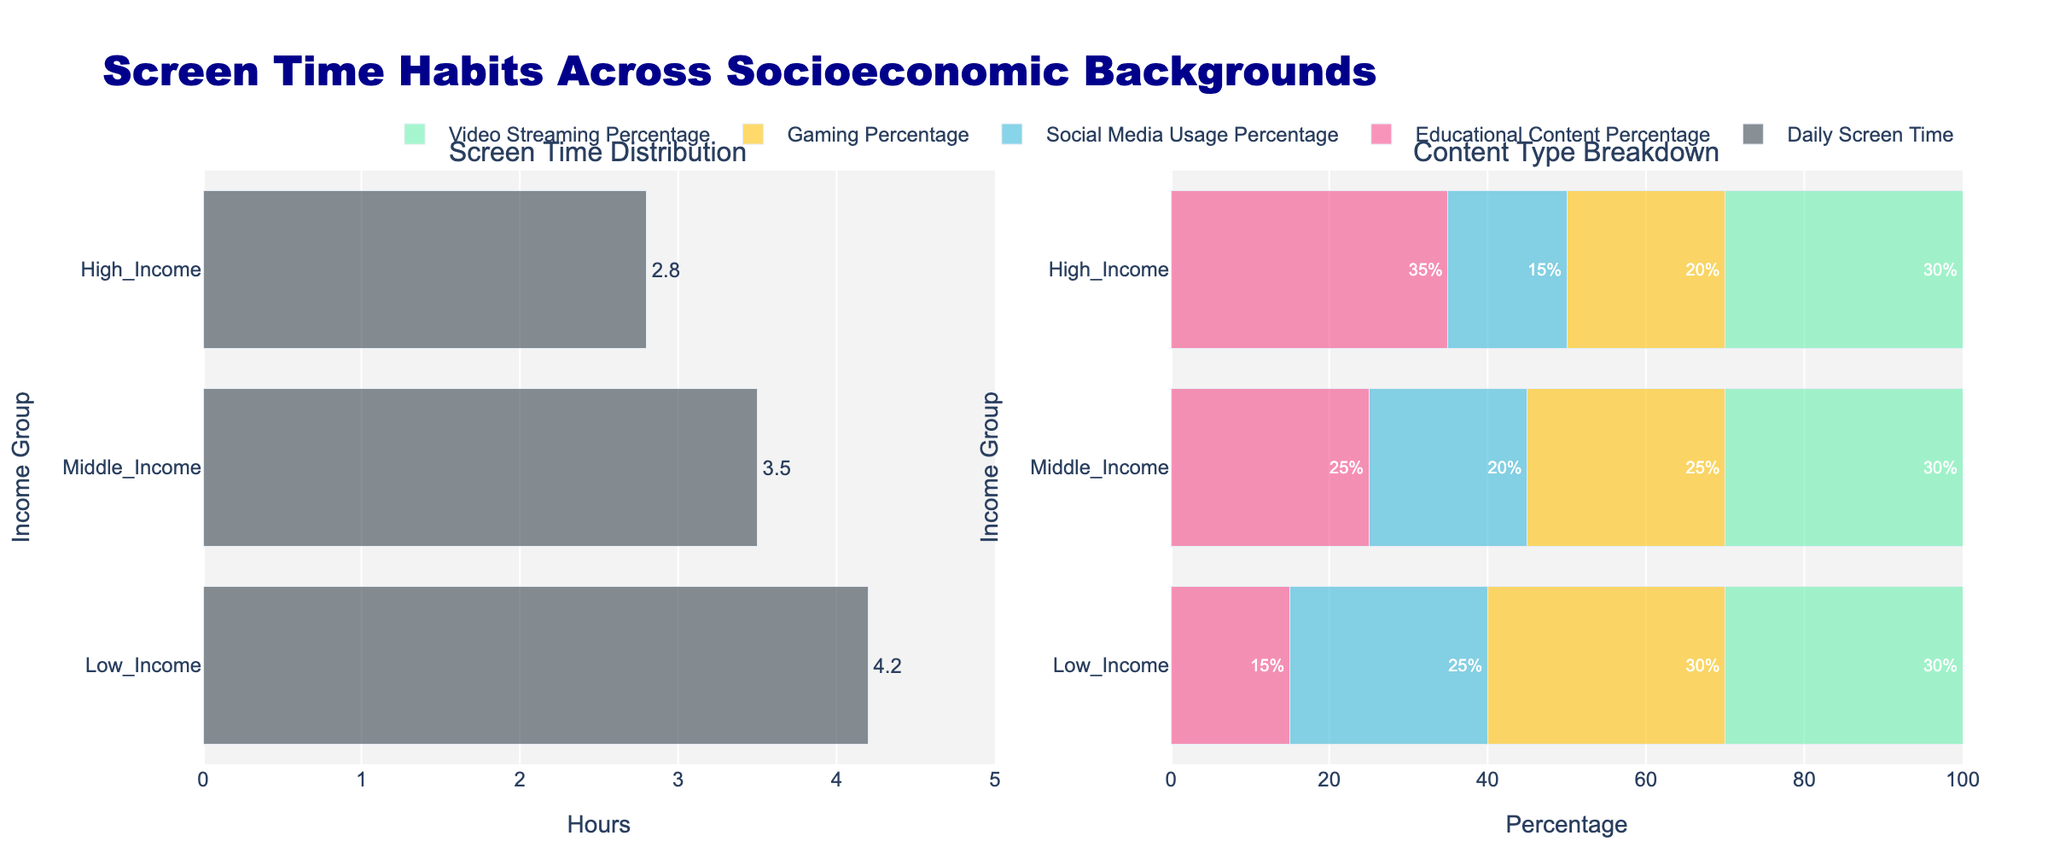What does the figure mainly illustrate? The title of the figure is "Screen Time Habits Across Socioeconomic Backgrounds" which suggests it is comparing screen time habits among children from different income groups across various activities. This includes overall daily screen time and a breakdown of content types.
Answer: Comparison of screen time habits among children from different socioeconomic backgrounds How many income groups are compared in the figure? By looking at the y-axis, the figure differentiates between three income groups: Low Income, Middle Income, and High Income.
Answer: Three Which income group shows the highest average daily screen time? By examining the bar chart on the left side, the bar representing Low Income group is the longest, indicating they have the highest daily screen time.
Answer: Low Income Which type of content has the highest percentage used by each income group? In the stacked bar chart on the right, for each income group, the segment labeled "Video Streaming Percentage" is the longest within each bar, which means video streaming has the highest percentage for all income groups.
Answer: Video streaming What is the combined percentage of educational content and video streaming for the Middle Income group? From the second chart, Middle Income group has 25% for Educational Content and 30% for Video Streaming. Adding these gives 25% + 30% = 55%.
Answer: 55% Which income group dedicates the most percentage to educational content? Looking at the longest Educational Content segment in the stacked bar chart, High Income group has the largest percentage at 35%.
Answer: High Income By how many hours is the Low Income group's daily screen time higher than the High Income group's? The Low Income group has 4.2 hours, while the High Income group has 2.8 hours. Subtracting 2.8 from 4.2 gives 4.2 - 2.8 = 1.4 hours.
Answer: 1.4 hours Which content type is more frequently used by the Low Income group compared to the High Income group? Comparing the segments in the stacked bar chart, Low Income group has higher percentages in both Social Media Usage (25%) and Gaming (30%) compared to the High Income group's 15% and 20% respectively.
Answer: Social Media Usage and Gaming What is the difference in daily screen time between the Middle Income and High Income groups? The Middle Income group has 3.5 hours of daily screen time while the High Income group has 2.8 hours. The difference is 3.5 - 2.8 = 0.7 hours.
Answer: 0.7 hours 